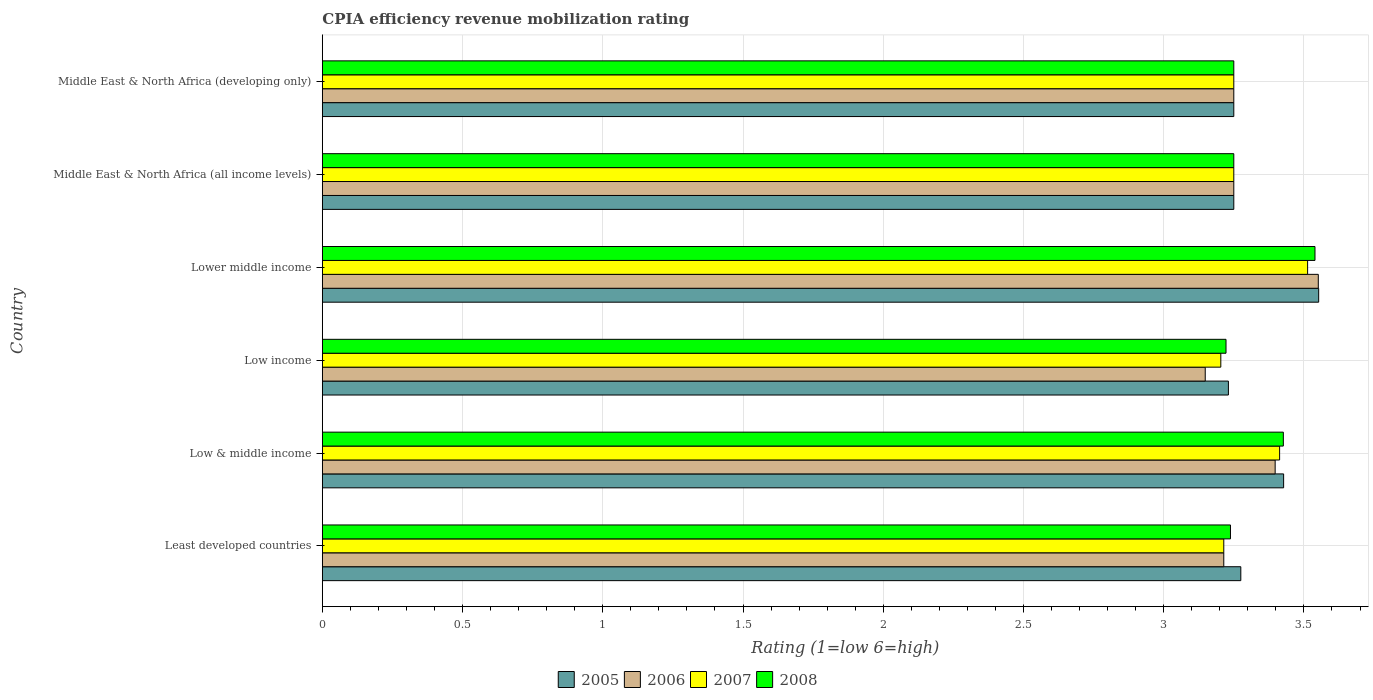How many different coloured bars are there?
Your answer should be compact. 4. How many groups of bars are there?
Keep it short and to the point. 6. Are the number of bars on each tick of the Y-axis equal?
Offer a very short reply. Yes. How many bars are there on the 6th tick from the top?
Keep it short and to the point. 4. What is the label of the 1st group of bars from the top?
Your answer should be compact. Middle East & North Africa (developing only). What is the CPIA rating in 2007 in Low & middle income?
Ensure brevity in your answer.  3.41. Across all countries, what is the maximum CPIA rating in 2008?
Ensure brevity in your answer.  3.54. Across all countries, what is the minimum CPIA rating in 2008?
Keep it short and to the point. 3.22. In which country was the CPIA rating in 2006 maximum?
Your answer should be very brief. Lower middle income. What is the total CPIA rating in 2006 in the graph?
Your answer should be compact. 19.81. What is the difference between the CPIA rating in 2006 in Least developed countries and that in Middle East & North Africa (developing only)?
Provide a succinct answer. -0.04. What is the difference between the CPIA rating in 2008 in Middle East & North Africa (all income levels) and the CPIA rating in 2007 in Low & middle income?
Offer a terse response. -0.16. What is the average CPIA rating in 2006 per country?
Ensure brevity in your answer.  3.3. What is the difference between the CPIA rating in 2006 and CPIA rating in 2008 in Least developed countries?
Give a very brief answer. -0.02. What is the ratio of the CPIA rating in 2008 in Least developed countries to that in Low & middle income?
Your answer should be compact. 0.94. Is the CPIA rating in 2008 in Low & middle income less than that in Middle East & North Africa (all income levels)?
Offer a terse response. No. Is the difference between the CPIA rating in 2006 in Lower middle income and Middle East & North Africa (developing only) greater than the difference between the CPIA rating in 2008 in Lower middle income and Middle East & North Africa (developing only)?
Your answer should be compact. Yes. What is the difference between the highest and the lowest CPIA rating in 2008?
Your answer should be very brief. 0.32. In how many countries, is the CPIA rating in 2007 greater than the average CPIA rating in 2007 taken over all countries?
Provide a succinct answer. 2. Is it the case that in every country, the sum of the CPIA rating in 2007 and CPIA rating in 2008 is greater than the sum of CPIA rating in 2005 and CPIA rating in 2006?
Provide a short and direct response. No. What does the 1st bar from the top in Middle East & North Africa (developing only) represents?
Make the answer very short. 2008. Is it the case that in every country, the sum of the CPIA rating in 2007 and CPIA rating in 2008 is greater than the CPIA rating in 2005?
Your response must be concise. Yes. What is the difference between two consecutive major ticks on the X-axis?
Keep it short and to the point. 0.5. Does the graph contain any zero values?
Offer a very short reply. No. Where does the legend appear in the graph?
Your response must be concise. Bottom center. What is the title of the graph?
Offer a very short reply. CPIA efficiency revenue mobilization rating. Does "2007" appear as one of the legend labels in the graph?
Your answer should be very brief. Yes. What is the label or title of the X-axis?
Provide a succinct answer. Rating (1=low 6=high). What is the label or title of the Y-axis?
Provide a short and direct response. Country. What is the Rating (1=low 6=high) in 2005 in Least developed countries?
Offer a very short reply. 3.27. What is the Rating (1=low 6=high) in 2006 in Least developed countries?
Keep it short and to the point. 3.21. What is the Rating (1=low 6=high) of 2007 in Least developed countries?
Give a very brief answer. 3.21. What is the Rating (1=low 6=high) of 2008 in Least developed countries?
Offer a terse response. 3.24. What is the Rating (1=low 6=high) of 2005 in Low & middle income?
Make the answer very short. 3.43. What is the Rating (1=low 6=high) of 2006 in Low & middle income?
Your answer should be compact. 3.4. What is the Rating (1=low 6=high) in 2007 in Low & middle income?
Provide a succinct answer. 3.41. What is the Rating (1=low 6=high) in 2008 in Low & middle income?
Your answer should be very brief. 3.43. What is the Rating (1=low 6=high) of 2005 in Low income?
Provide a succinct answer. 3.23. What is the Rating (1=low 6=high) in 2006 in Low income?
Ensure brevity in your answer.  3.15. What is the Rating (1=low 6=high) of 2007 in Low income?
Offer a very short reply. 3.2. What is the Rating (1=low 6=high) in 2008 in Low income?
Provide a short and direct response. 3.22. What is the Rating (1=low 6=high) of 2005 in Lower middle income?
Provide a succinct answer. 3.55. What is the Rating (1=low 6=high) of 2006 in Lower middle income?
Your response must be concise. 3.55. What is the Rating (1=low 6=high) of 2007 in Lower middle income?
Make the answer very short. 3.51. What is the Rating (1=low 6=high) of 2008 in Lower middle income?
Offer a terse response. 3.54. What is the Rating (1=low 6=high) of 2005 in Middle East & North Africa (all income levels)?
Provide a short and direct response. 3.25. What is the Rating (1=low 6=high) of 2007 in Middle East & North Africa (all income levels)?
Keep it short and to the point. 3.25. What is the Rating (1=low 6=high) of 2008 in Middle East & North Africa (all income levels)?
Your answer should be very brief. 3.25. What is the Rating (1=low 6=high) of 2005 in Middle East & North Africa (developing only)?
Your answer should be compact. 3.25. What is the Rating (1=low 6=high) in 2008 in Middle East & North Africa (developing only)?
Offer a terse response. 3.25. Across all countries, what is the maximum Rating (1=low 6=high) of 2005?
Make the answer very short. 3.55. Across all countries, what is the maximum Rating (1=low 6=high) of 2006?
Give a very brief answer. 3.55. Across all countries, what is the maximum Rating (1=low 6=high) in 2007?
Your answer should be compact. 3.51. Across all countries, what is the maximum Rating (1=low 6=high) in 2008?
Keep it short and to the point. 3.54. Across all countries, what is the minimum Rating (1=low 6=high) of 2005?
Your response must be concise. 3.23. Across all countries, what is the minimum Rating (1=low 6=high) in 2006?
Ensure brevity in your answer.  3.15. Across all countries, what is the minimum Rating (1=low 6=high) of 2007?
Give a very brief answer. 3.2. Across all countries, what is the minimum Rating (1=low 6=high) of 2008?
Give a very brief answer. 3.22. What is the total Rating (1=low 6=high) of 2005 in the graph?
Your answer should be compact. 19.99. What is the total Rating (1=low 6=high) in 2006 in the graph?
Your answer should be compact. 19.81. What is the total Rating (1=low 6=high) of 2007 in the graph?
Your answer should be very brief. 19.84. What is the total Rating (1=low 6=high) in 2008 in the graph?
Offer a very short reply. 19.93. What is the difference between the Rating (1=low 6=high) of 2005 in Least developed countries and that in Low & middle income?
Ensure brevity in your answer.  -0.15. What is the difference between the Rating (1=low 6=high) in 2006 in Least developed countries and that in Low & middle income?
Your response must be concise. -0.18. What is the difference between the Rating (1=low 6=high) of 2007 in Least developed countries and that in Low & middle income?
Make the answer very short. -0.2. What is the difference between the Rating (1=low 6=high) in 2008 in Least developed countries and that in Low & middle income?
Offer a very short reply. -0.19. What is the difference between the Rating (1=low 6=high) of 2005 in Least developed countries and that in Low income?
Ensure brevity in your answer.  0.04. What is the difference between the Rating (1=low 6=high) in 2006 in Least developed countries and that in Low income?
Your answer should be very brief. 0.07. What is the difference between the Rating (1=low 6=high) of 2007 in Least developed countries and that in Low income?
Keep it short and to the point. 0.01. What is the difference between the Rating (1=low 6=high) in 2008 in Least developed countries and that in Low income?
Your response must be concise. 0.02. What is the difference between the Rating (1=low 6=high) of 2005 in Least developed countries and that in Lower middle income?
Your answer should be compact. -0.28. What is the difference between the Rating (1=low 6=high) in 2006 in Least developed countries and that in Lower middle income?
Provide a succinct answer. -0.34. What is the difference between the Rating (1=low 6=high) of 2007 in Least developed countries and that in Lower middle income?
Your answer should be compact. -0.3. What is the difference between the Rating (1=low 6=high) in 2008 in Least developed countries and that in Lower middle income?
Offer a terse response. -0.3. What is the difference between the Rating (1=low 6=high) of 2005 in Least developed countries and that in Middle East & North Africa (all income levels)?
Ensure brevity in your answer.  0.03. What is the difference between the Rating (1=low 6=high) in 2006 in Least developed countries and that in Middle East & North Africa (all income levels)?
Offer a very short reply. -0.04. What is the difference between the Rating (1=low 6=high) of 2007 in Least developed countries and that in Middle East & North Africa (all income levels)?
Make the answer very short. -0.04. What is the difference between the Rating (1=low 6=high) in 2008 in Least developed countries and that in Middle East & North Africa (all income levels)?
Provide a short and direct response. -0.01. What is the difference between the Rating (1=low 6=high) of 2005 in Least developed countries and that in Middle East & North Africa (developing only)?
Give a very brief answer. 0.03. What is the difference between the Rating (1=low 6=high) of 2006 in Least developed countries and that in Middle East & North Africa (developing only)?
Give a very brief answer. -0.04. What is the difference between the Rating (1=low 6=high) of 2007 in Least developed countries and that in Middle East & North Africa (developing only)?
Make the answer very short. -0.04. What is the difference between the Rating (1=low 6=high) of 2008 in Least developed countries and that in Middle East & North Africa (developing only)?
Ensure brevity in your answer.  -0.01. What is the difference between the Rating (1=low 6=high) in 2005 in Low & middle income and that in Low income?
Keep it short and to the point. 0.2. What is the difference between the Rating (1=low 6=high) of 2006 in Low & middle income and that in Low income?
Give a very brief answer. 0.25. What is the difference between the Rating (1=low 6=high) of 2007 in Low & middle income and that in Low income?
Keep it short and to the point. 0.21. What is the difference between the Rating (1=low 6=high) in 2008 in Low & middle income and that in Low income?
Provide a succinct answer. 0.2. What is the difference between the Rating (1=low 6=high) of 2005 in Low & middle income and that in Lower middle income?
Make the answer very short. -0.12. What is the difference between the Rating (1=low 6=high) in 2006 in Low & middle income and that in Lower middle income?
Provide a succinct answer. -0.15. What is the difference between the Rating (1=low 6=high) of 2007 in Low & middle income and that in Lower middle income?
Ensure brevity in your answer.  -0.1. What is the difference between the Rating (1=low 6=high) of 2008 in Low & middle income and that in Lower middle income?
Your answer should be very brief. -0.11. What is the difference between the Rating (1=low 6=high) of 2005 in Low & middle income and that in Middle East & North Africa (all income levels)?
Give a very brief answer. 0.18. What is the difference between the Rating (1=low 6=high) in 2006 in Low & middle income and that in Middle East & North Africa (all income levels)?
Your response must be concise. 0.15. What is the difference between the Rating (1=low 6=high) in 2007 in Low & middle income and that in Middle East & North Africa (all income levels)?
Make the answer very short. 0.16. What is the difference between the Rating (1=low 6=high) in 2008 in Low & middle income and that in Middle East & North Africa (all income levels)?
Provide a succinct answer. 0.18. What is the difference between the Rating (1=low 6=high) of 2005 in Low & middle income and that in Middle East & North Africa (developing only)?
Give a very brief answer. 0.18. What is the difference between the Rating (1=low 6=high) of 2006 in Low & middle income and that in Middle East & North Africa (developing only)?
Offer a terse response. 0.15. What is the difference between the Rating (1=low 6=high) in 2007 in Low & middle income and that in Middle East & North Africa (developing only)?
Ensure brevity in your answer.  0.16. What is the difference between the Rating (1=low 6=high) of 2008 in Low & middle income and that in Middle East & North Africa (developing only)?
Provide a succinct answer. 0.18. What is the difference between the Rating (1=low 6=high) in 2005 in Low income and that in Lower middle income?
Ensure brevity in your answer.  -0.32. What is the difference between the Rating (1=low 6=high) of 2006 in Low income and that in Lower middle income?
Your answer should be compact. -0.4. What is the difference between the Rating (1=low 6=high) of 2007 in Low income and that in Lower middle income?
Give a very brief answer. -0.31. What is the difference between the Rating (1=low 6=high) in 2008 in Low income and that in Lower middle income?
Keep it short and to the point. -0.32. What is the difference between the Rating (1=low 6=high) of 2005 in Low income and that in Middle East & North Africa (all income levels)?
Keep it short and to the point. -0.02. What is the difference between the Rating (1=low 6=high) in 2006 in Low income and that in Middle East & North Africa (all income levels)?
Offer a terse response. -0.1. What is the difference between the Rating (1=low 6=high) in 2007 in Low income and that in Middle East & North Africa (all income levels)?
Provide a short and direct response. -0.05. What is the difference between the Rating (1=low 6=high) of 2008 in Low income and that in Middle East & North Africa (all income levels)?
Provide a short and direct response. -0.03. What is the difference between the Rating (1=low 6=high) in 2005 in Low income and that in Middle East & North Africa (developing only)?
Offer a terse response. -0.02. What is the difference between the Rating (1=low 6=high) in 2006 in Low income and that in Middle East & North Africa (developing only)?
Give a very brief answer. -0.1. What is the difference between the Rating (1=low 6=high) of 2007 in Low income and that in Middle East & North Africa (developing only)?
Make the answer very short. -0.05. What is the difference between the Rating (1=low 6=high) of 2008 in Low income and that in Middle East & North Africa (developing only)?
Offer a terse response. -0.03. What is the difference between the Rating (1=low 6=high) in 2005 in Lower middle income and that in Middle East & North Africa (all income levels)?
Provide a short and direct response. 0.3. What is the difference between the Rating (1=low 6=high) of 2006 in Lower middle income and that in Middle East & North Africa (all income levels)?
Your answer should be compact. 0.3. What is the difference between the Rating (1=low 6=high) of 2007 in Lower middle income and that in Middle East & North Africa (all income levels)?
Make the answer very short. 0.26. What is the difference between the Rating (1=low 6=high) of 2008 in Lower middle income and that in Middle East & North Africa (all income levels)?
Provide a short and direct response. 0.29. What is the difference between the Rating (1=low 6=high) in 2005 in Lower middle income and that in Middle East & North Africa (developing only)?
Offer a terse response. 0.3. What is the difference between the Rating (1=low 6=high) of 2006 in Lower middle income and that in Middle East & North Africa (developing only)?
Give a very brief answer. 0.3. What is the difference between the Rating (1=low 6=high) of 2007 in Lower middle income and that in Middle East & North Africa (developing only)?
Offer a terse response. 0.26. What is the difference between the Rating (1=low 6=high) in 2008 in Lower middle income and that in Middle East & North Africa (developing only)?
Give a very brief answer. 0.29. What is the difference between the Rating (1=low 6=high) of 2006 in Middle East & North Africa (all income levels) and that in Middle East & North Africa (developing only)?
Provide a short and direct response. 0. What is the difference between the Rating (1=low 6=high) of 2008 in Middle East & North Africa (all income levels) and that in Middle East & North Africa (developing only)?
Give a very brief answer. 0. What is the difference between the Rating (1=low 6=high) of 2005 in Least developed countries and the Rating (1=low 6=high) of 2006 in Low & middle income?
Keep it short and to the point. -0.12. What is the difference between the Rating (1=low 6=high) in 2005 in Least developed countries and the Rating (1=low 6=high) in 2007 in Low & middle income?
Your answer should be compact. -0.14. What is the difference between the Rating (1=low 6=high) in 2005 in Least developed countries and the Rating (1=low 6=high) in 2008 in Low & middle income?
Give a very brief answer. -0.15. What is the difference between the Rating (1=low 6=high) in 2006 in Least developed countries and the Rating (1=low 6=high) in 2007 in Low & middle income?
Provide a short and direct response. -0.2. What is the difference between the Rating (1=low 6=high) of 2006 in Least developed countries and the Rating (1=low 6=high) of 2008 in Low & middle income?
Offer a very short reply. -0.21. What is the difference between the Rating (1=low 6=high) of 2007 in Least developed countries and the Rating (1=low 6=high) of 2008 in Low & middle income?
Your response must be concise. -0.21. What is the difference between the Rating (1=low 6=high) in 2005 in Least developed countries and the Rating (1=low 6=high) in 2006 in Low income?
Offer a terse response. 0.13. What is the difference between the Rating (1=low 6=high) of 2005 in Least developed countries and the Rating (1=low 6=high) of 2007 in Low income?
Offer a very short reply. 0.07. What is the difference between the Rating (1=low 6=high) in 2005 in Least developed countries and the Rating (1=low 6=high) in 2008 in Low income?
Offer a very short reply. 0.05. What is the difference between the Rating (1=low 6=high) in 2006 in Least developed countries and the Rating (1=low 6=high) in 2007 in Low income?
Your answer should be compact. 0.01. What is the difference between the Rating (1=low 6=high) of 2006 in Least developed countries and the Rating (1=low 6=high) of 2008 in Low income?
Provide a succinct answer. -0.01. What is the difference between the Rating (1=low 6=high) in 2007 in Least developed countries and the Rating (1=low 6=high) in 2008 in Low income?
Provide a succinct answer. -0.01. What is the difference between the Rating (1=low 6=high) of 2005 in Least developed countries and the Rating (1=low 6=high) of 2006 in Lower middle income?
Give a very brief answer. -0.28. What is the difference between the Rating (1=low 6=high) in 2005 in Least developed countries and the Rating (1=low 6=high) in 2007 in Lower middle income?
Provide a short and direct response. -0.24. What is the difference between the Rating (1=low 6=high) in 2005 in Least developed countries and the Rating (1=low 6=high) in 2008 in Lower middle income?
Give a very brief answer. -0.26. What is the difference between the Rating (1=low 6=high) in 2006 in Least developed countries and the Rating (1=low 6=high) in 2007 in Lower middle income?
Your answer should be very brief. -0.3. What is the difference between the Rating (1=low 6=high) in 2006 in Least developed countries and the Rating (1=low 6=high) in 2008 in Lower middle income?
Provide a short and direct response. -0.33. What is the difference between the Rating (1=low 6=high) in 2007 in Least developed countries and the Rating (1=low 6=high) in 2008 in Lower middle income?
Give a very brief answer. -0.33. What is the difference between the Rating (1=low 6=high) in 2005 in Least developed countries and the Rating (1=low 6=high) in 2006 in Middle East & North Africa (all income levels)?
Ensure brevity in your answer.  0.03. What is the difference between the Rating (1=low 6=high) in 2005 in Least developed countries and the Rating (1=low 6=high) in 2007 in Middle East & North Africa (all income levels)?
Offer a very short reply. 0.03. What is the difference between the Rating (1=low 6=high) of 2005 in Least developed countries and the Rating (1=low 6=high) of 2008 in Middle East & North Africa (all income levels)?
Offer a very short reply. 0.03. What is the difference between the Rating (1=low 6=high) of 2006 in Least developed countries and the Rating (1=low 6=high) of 2007 in Middle East & North Africa (all income levels)?
Provide a short and direct response. -0.04. What is the difference between the Rating (1=low 6=high) in 2006 in Least developed countries and the Rating (1=low 6=high) in 2008 in Middle East & North Africa (all income levels)?
Make the answer very short. -0.04. What is the difference between the Rating (1=low 6=high) of 2007 in Least developed countries and the Rating (1=low 6=high) of 2008 in Middle East & North Africa (all income levels)?
Your answer should be very brief. -0.04. What is the difference between the Rating (1=low 6=high) in 2005 in Least developed countries and the Rating (1=low 6=high) in 2006 in Middle East & North Africa (developing only)?
Make the answer very short. 0.03. What is the difference between the Rating (1=low 6=high) in 2005 in Least developed countries and the Rating (1=low 6=high) in 2007 in Middle East & North Africa (developing only)?
Provide a short and direct response. 0.03. What is the difference between the Rating (1=low 6=high) of 2005 in Least developed countries and the Rating (1=low 6=high) of 2008 in Middle East & North Africa (developing only)?
Make the answer very short. 0.03. What is the difference between the Rating (1=low 6=high) in 2006 in Least developed countries and the Rating (1=low 6=high) in 2007 in Middle East & North Africa (developing only)?
Your answer should be compact. -0.04. What is the difference between the Rating (1=low 6=high) in 2006 in Least developed countries and the Rating (1=low 6=high) in 2008 in Middle East & North Africa (developing only)?
Offer a very short reply. -0.04. What is the difference between the Rating (1=low 6=high) in 2007 in Least developed countries and the Rating (1=low 6=high) in 2008 in Middle East & North Africa (developing only)?
Offer a terse response. -0.04. What is the difference between the Rating (1=low 6=high) of 2005 in Low & middle income and the Rating (1=low 6=high) of 2006 in Low income?
Ensure brevity in your answer.  0.28. What is the difference between the Rating (1=low 6=high) of 2005 in Low & middle income and the Rating (1=low 6=high) of 2007 in Low income?
Offer a terse response. 0.22. What is the difference between the Rating (1=low 6=high) of 2005 in Low & middle income and the Rating (1=low 6=high) of 2008 in Low income?
Give a very brief answer. 0.21. What is the difference between the Rating (1=low 6=high) of 2006 in Low & middle income and the Rating (1=low 6=high) of 2007 in Low income?
Keep it short and to the point. 0.19. What is the difference between the Rating (1=low 6=high) of 2006 in Low & middle income and the Rating (1=low 6=high) of 2008 in Low income?
Make the answer very short. 0.18. What is the difference between the Rating (1=low 6=high) in 2007 in Low & middle income and the Rating (1=low 6=high) in 2008 in Low income?
Your response must be concise. 0.19. What is the difference between the Rating (1=low 6=high) in 2005 in Low & middle income and the Rating (1=low 6=high) in 2006 in Lower middle income?
Offer a terse response. -0.12. What is the difference between the Rating (1=low 6=high) in 2005 in Low & middle income and the Rating (1=low 6=high) in 2007 in Lower middle income?
Keep it short and to the point. -0.09. What is the difference between the Rating (1=low 6=high) of 2005 in Low & middle income and the Rating (1=low 6=high) of 2008 in Lower middle income?
Give a very brief answer. -0.11. What is the difference between the Rating (1=low 6=high) in 2006 in Low & middle income and the Rating (1=low 6=high) in 2007 in Lower middle income?
Offer a terse response. -0.12. What is the difference between the Rating (1=low 6=high) in 2006 in Low & middle income and the Rating (1=low 6=high) in 2008 in Lower middle income?
Ensure brevity in your answer.  -0.14. What is the difference between the Rating (1=low 6=high) of 2007 in Low & middle income and the Rating (1=low 6=high) of 2008 in Lower middle income?
Provide a succinct answer. -0.13. What is the difference between the Rating (1=low 6=high) of 2005 in Low & middle income and the Rating (1=low 6=high) of 2006 in Middle East & North Africa (all income levels)?
Your response must be concise. 0.18. What is the difference between the Rating (1=low 6=high) of 2005 in Low & middle income and the Rating (1=low 6=high) of 2007 in Middle East & North Africa (all income levels)?
Your answer should be very brief. 0.18. What is the difference between the Rating (1=low 6=high) of 2005 in Low & middle income and the Rating (1=low 6=high) of 2008 in Middle East & North Africa (all income levels)?
Provide a succinct answer. 0.18. What is the difference between the Rating (1=low 6=high) of 2006 in Low & middle income and the Rating (1=low 6=high) of 2007 in Middle East & North Africa (all income levels)?
Ensure brevity in your answer.  0.15. What is the difference between the Rating (1=low 6=high) in 2006 in Low & middle income and the Rating (1=low 6=high) in 2008 in Middle East & North Africa (all income levels)?
Your answer should be very brief. 0.15. What is the difference between the Rating (1=low 6=high) of 2007 in Low & middle income and the Rating (1=low 6=high) of 2008 in Middle East & North Africa (all income levels)?
Offer a terse response. 0.16. What is the difference between the Rating (1=low 6=high) in 2005 in Low & middle income and the Rating (1=low 6=high) in 2006 in Middle East & North Africa (developing only)?
Your answer should be compact. 0.18. What is the difference between the Rating (1=low 6=high) in 2005 in Low & middle income and the Rating (1=low 6=high) in 2007 in Middle East & North Africa (developing only)?
Give a very brief answer. 0.18. What is the difference between the Rating (1=low 6=high) of 2005 in Low & middle income and the Rating (1=low 6=high) of 2008 in Middle East & North Africa (developing only)?
Keep it short and to the point. 0.18. What is the difference between the Rating (1=low 6=high) in 2006 in Low & middle income and the Rating (1=low 6=high) in 2007 in Middle East & North Africa (developing only)?
Ensure brevity in your answer.  0.15. What is the difference between the Rating (1=low 6=high) of 2006 in Low & middle income and the Rating (1=low 6=high) of 2008 in Middle East & North Africa (developing only)?
Provide a succinct answer. 0.15. What is the difference between the Rating (1=low 6=high) of 2007 in Low & middle income and the Rating (1=low 6=high) of 2008 in Middle East & North Africa (developing only)?
Provide a succinct answer. 0.16. What is the difference between the Rating (1=low 6=high) in 2005 in Low income and the Rating (1=low 6=high) in 2006 in Lower middle income?
Ensure brevity in your answer.  -0.32. What is the difference between the Rating (1=low 6=high) of 2005 in Low income and the Rating (1=low 6=high) of 2007 in Lower middle income?
Offer a very short reply. -0.28. What is the difference between the Rating (1=low 6=high) of 2005 in Low income and the Rating (1=low 6=high) of 2008 in Lower middle income?
Provide a short and direct response. -0.31. What is the difference between the Rating (1=low 6=high) in 2006 in Low income and the Rating (1=low 6=high) in 2007 in Lower middle income?
Your response must be concise. -0.36. What is the difference between the Rating (1=low 6=high) of 2006 in Low income and the Rating (1=low 6=high) of 2008 in Lower middle income?
Your response must be concise. -0.39. What is the difference between the Rating (1=low 6=high) in 2007 in Low income and the Rating (1=low 6=high) in 2008 in Lower middle income?
Ensure brevity in your answer.  -0.34. What is the difference between the Rating (1=low 6=high) in 2005 in Low income and the Rating (1=low 6=high) in 2006 in Middle East & North Africa (all income levels)?
Provide a short and direct response. -0.02. What is the difference between the Rating (1=low 6=high) of 2005 in Low income and the Rating (1=low 6=high) of 2007 in Middle East & North Africa (all income levels)?
Make the answer very short. -0.02. What is the difference between the Rating (1=low 6=high) in 2005 in Low income and the Rating (1=low 6=high) in 2008 in Middle East & North Africa (all income levels)?
Ensure brevity in your answer.  -0.02. What is the difference between the Rating (1=low 6=high) in 2006 in Low income and the Rating (1=low 6=high) in 2007 in Middle East & North Africa (all income levels)?
Offer a terse response. -0.1. What is the difference between the Rating (1=low 6=high) of 2006 in Low income and the Rating (1=low 6=high) of 2008 in Middle East & North Africa (all income levels)?
Ensure brevity in your answer.  -0.1. What is the difference between the Rating (1=low 6=high) of 2007 in Low income and the Rating (1=low 6=high) of 2008 in Middle East & North Africa (all income levels)?
Ensure brevity in your answer.  -0.05. What is the difference between the Rating (1=low 6=high) in 2005 in Low income and the Rating (1=low 6=high) in 2006 in Middle East & North Africa (developing only)?
Make the answer very short. -0.02. What is the difference between the Rating (1=low 6=high) in 2005 in Low income and the Rating (1=low 6=high) in 2007 in Middle East & North Africa (developing only)?
Ensure brevity in your answer.  -0.02. What is the difference between the Rating (1=low 6=high) in 2005 in Low income and the Rating (1=low 6=high) in 2008 in Middle East & North Africa (developing only)?
Offer a very short reply. -0.02. What is the difference between the Rating (1=low 6=high) in 2006 in Low income and the Rating (1=low 6=high) in 2007 in Middle East & North Africa (developing only)?
Offer a terse response. -0.1. What is the difference between the Rating (1=low 6=high) of 2006 in Low income and the Rating (1=low 6=high) of 2008 in Middle East & North Africa (developing only)?
Provide a succinct answer. -0.1. What is the difference between the Rating (1=low 6=high) in 2007 in Low income and the Rating (1=low 6=high) in 2008 in Middle East & North Africa (developing only)?
Your answer should be compact. -0.05. What is the difference between the Rating (1=low 6=high) in 2005 in Lower middle income and the Rating (1=low 6=high) in 2006 in Middle East & North Africa (all income levels)?
Offer a terse response. 0.3. What is the difference between the Rating (1=low 6=high) of 2005 in Lower middle income and the Rating (1=low 6=high) of 2007 in Middle East & North Africa (all income levels)?
Make the answer very short. 0.3. What is the difference between the Rating (1=low 6=high) of 2005 in Lower middle income and the Rating (1=low 6=high) of 2008 in Middle East & North Africa (all income levels)?
Your answer should be compact. 0.3. What is the difference between the Rating (1=low 6=high) of 2006 in Lower middle income and the Rating (1=low 6=high) of 2007 in Middle East & North Africa (all income levels)?
Provide a short and direct response. 0.3. What is the difference between the Rating (1=low 6=high) of 2006 in Lower middle income and the Rating (1=low 6=high) of 2008 in Middle East & North Africa (all income levels)?
Keep it short and to the point. 0.3. What is the difference between the Rating (1=low 6=high) in 2007 in Lower middle income and the Rating (1=low 6=high) in 2008 in Middle East & North Africa (all income levels)?
Your answer should be very brief. 0.26. What is the difference between the Rating (1=low 6=high) of 2005 in Lower middle income and the Rating (1=low 6=high) of 2006 in Middle East & North Africa (developing only)?
Provide a succinct answer. 0.3. What is the difference between the Rating (1=low 6=high) in 2005 in Lower middle income and the Rating (1=low 6=high) in 2007 in Middle East & North Africa (developing only)?
Your answer should be very brief. 0.3. What is the difference between the Rating (1=low 6=high) in 2005 in Lower middle income and the Rating (1=low 6=high) in 2008 in Middle East & North Africa (developing only)?
Give a very brief answer. 0.3. What is the difference between the Rating (1=low 6=high) in 2006 in Lower middle income and the Rating (1=low 6=high) in 2007 in Middle East & North Africa (developing only)?
Your answer should be compact. 0.3. What is the difference between the Rating (1=low 6=high) of 2006 in Lower middle income and the Rating (1=low 6=high) of 2008 in Middle East & North Africa (developing only)?
Provide a succinct answer. 0.3. What is the difference between the Rating (1=low 6=high) of 2007 in Lower middle income and the Rating (1=low 6=high) of 2008 in Middle East & North Africa (developing only)?
Offer a very short reply. 0.26. What is the difference between the Rating (1=low 6=high) of 2006 in Middle East & North Africa (all income levels) and the Rating (1=low 6=high) of 2008 in Middle East & North Africa (developing only)?
Offer a very short reply. 0. What is the difference between the Rating (1=low 6=high) of 2007 in Middle East & North Africa (all income levels) and the Rating (1=low 6=high) of 2008 in Middle East & North Africa (developing only)?
Ensure brevity in your answer.  0. What is the average Rating (1=low 6=high) of 2005 per country?
Offer a terse response. 3.33. What is the average Rating (1=low 6=high) in 2006 per country?
Your answer should be compact. 3.3. What is the average Rating (1=low 6=high) in 2007 per country?
Keep it short and to the point. 3.31. What is the average Rating (1=low 6=high) in 2008 per country?
Provide a succinct answer. 3.32. What is the difference between the Rating (1=low 6=high) of 2005 and Rating (1=low 6=high) of 2006 in Least developed countries?
Ensure brevity in your answer.  0.06. What is the difference between the Rating (1=low 6=high) in 2005 and Rating (1=low 6=high) in 2007 in Least developed countries?
Give a very brief answer. 0.06. What is the difference between the Rating (1=low 6=high) in 2005 and Rating (1=low 6=high) in 2008 in Least developed countries?
Give a very brief answer. 0.04. What is the difference between the Rating (1=low 6=high) of 2006 and Rating (1=low 6=high) of 2008 in Least developed countries?
Ensure brevity in your answer.  -0.02. What is the difference between the Rating (1=low 6=high) of 2007 and Rating (1=low 6=high) of 2008 in Least developed countries?
Give a very brief answer. -0.02. What is the difference between the Rating (1=low 6=high) in 2005 and Rating (1=low 6=high) in 2006 in Low & middle income?
Your answer should be compact. 0.03. What is the difference between the Rating (1=low 6=high) of 2005 and Rating (1=low 6=high) of 2007 in Low & middle income?
Ensure brevity in your answer.  0.01. What is the difference between the Rating (1=low 6=high) in 2006 and Rating (1=low 6=high) in 2007 in Low & middle income?
Keep it short and to the point. -0.02. What is the difference between the Rating (1=low 6=high) in 2006 and Rating (1=low 6=high) in 2008 in Low & middle income?
Offer a terse response. -0.03. What is the difference between the Rating (1=low 6=high) of 2007 and Rating (1=low 6=high) of 2008 in Low & middle income?
Your response must be concise. -0.01. What is the difference between the Rating (1=low 6=high) in 2005 and Rating (1=low 6=high) in 2006 in Low income?
Your answer should be compact. 0.08. What is the difference between the Rating (1=low 6=high) in 2005 and Rating (1=low 6=high) in 2007 in Low income?
Make the answer very short. 0.03. What is the difference between the Rating (1=low 6=high) of 2005 and Rating (1=low 6=high) of 2008 in Low income?
Ensure brevity in your answer.  0.01. What is the difference between the Rating (1=low 6=high) of 2006 and Rating (1=low 6=high) of 2007 in Low income?
Provide a succinct answer. -0.06. What is the difference between the Rating (1=low 6=high) in 2006 and Rating (1=low 6=high) in 2008 in Low income?
Your response must be concise. -0.07. What is the difference between the Rating (1=low 6=high) of 2007 and Rating (1=low 6=high) of 2008 in Low income?
Offer a terse response. -0.02. What is the difference between the Rating (1=low 6=high) of 2005 and Rating (1=low 6=high) of 2006 in Lower middle income?
Ensure brevity in your answer.  0. What is the difference between the Rating (1=low 6=high) of 2005 and Rating (1=low 6=high) of 2007 in Lower middle income?
Ensure brevity in your answer.  0.04. What is the difference between the Rating (1=low 6=high) of 2005 and Rating (1=low 6=high) of 2008 in Lower middle income?
Give a very brief answer. 0.01. What is the difference between the Rating (1=low 6=high) of 2006 and Rating (1=low 6=high) of 2007 in Lower middle income?
Ensure brevity in your answer.  0.04. What is the difference between the Rating (1=low 6=high) of 2006 and Rating (1=low 6=high) of 2008 in Lower middle income?
Offer a very short reply. 0.01. What is the difference between the Rating (1=low 6=high) in 2007 and Rating (1=low 6=high) in 2008 in Lower middle income?
Make the answer very short. -0.03. What is the difference between the Rating (1=low 6=high) of 2005 and Rating (1=low 6=high) of 2006 in Middle East & North Africa (all income levels)?
Offer a terse response. 0. What is the difference between the Rating (1=low 6=high) in 2006 and Rating (1=low 6=high) in 2007 in Middle East & North Africa (all income levels)?
Your answer should be very brief. 0. What is the difference between the Rating (1=low 6=high) of 2005 and Rating (1=low 6=high) of 2006 in Middle East & North Africa (developing only)?
Your response must be concise. 0. What is the difference between the Rating (1=low 6=high) in 2005 and Rating (1=low 6=high) in 2007 in Middle East & North Africa (developing only)?
Provide a short and direct response. 0. What is the difference between the Rating (1=low 6=high) of 2006 and Rating (1=low 6=high) of 2008 in Middle East & North Africa (developing only)?
Ensure brevity in your answer.  0. What is the difference between the Rating (1=low 6=high) of 2007 and Rating (1=low 6=high) of 2008 in Middle East & North Africa (developing only)?
Make the answer very short. 0. What is the ratio of the Rating (1=low 6=high) in 2005 in Least developed countries to that in Low & middle income?
Make the answer very short. 0.96. What is the ratio of the Rating (1=low 6=high) of 2006 in Least developed countries to that in Low & middle income?
Your response must be concise. 0.95. What is the ratio of the Rating (1=low 6=high) in 2007 in Least developed countries to that in Low & middle income?
Your answer should be compact. 0.94. What is the ratio of the Rating (1=low 6=high) in 2008 in Least developed countries to that in Low & middle income?
Offer a very short reply. 0.94. What is the ratio of the Rating (1=low 6=high) in 2005 in Least developed countries to that in Low income?
Keep it short and to the point. 1.01. What is the ratio of the Rating (1=low 6=high) of 2006 in Least developed countries to that in Low income?
Your answer should be very brief. 1.02. What is the ratio of the Rating (1=low 6=high) in 2008 in Least developed countries to that in Low income?
Your answer should be compact. 1. What is the ratio of the Rating (1=low 6=high) of 2005 in Least developed countries to that in Lower middle income?
Offer a very short reply. 0.92. What is the ratio of the Rating (1=low 6=high) of 2006 in Least developed countries to that in Lower middle income?
Make the answer very short. 0.91. What is the ratio of the Rating (1=low 6=high) of 2007 in Least developed countries to that in Lower middle income?
Give a very brief answer. 0.91. What is the ratio of the Rating (1=low 6=high) in 2008 in Least developed countries to that in Lower middle income?
Provide a short and direct response. 0.91. What is the ratio of the Rating (1=low 6=high) in 2005 in Least developed countries to that in Middle East & North Africa (all income levels)?
Offer a very short reply. 1.01. What is the ratio of the Rating (1=low 6=high) in 2006 in Least developed countries to that in Middle East & North Africa (all income levels)?
Make the answer very short. 0.99. What is the ratio of the Rating (1=low 6=high) in 2005 in Least developed countries to that in Middle East & North Africa (developing only)?
Provide a succinct answer. 1.01. What is the ratio of the Rating (1=low 6=high) in 2007 in Least developed countries to that in Middle East & North Africa (developing only)?
Provide a succinct answer. 0.99. What is the ratio of the Rating (1=low 6=high) of 2008 in Least developed countries to that in Middle East & North Africa (developing only)?
Provide a short and direct response. 1. What is the ratio of the Rating (1=low 6=high) in 2005 in Low & middle income to that in Low income?
Offer a very short reply. 1.06. What is the ratio of the Rating (1=low 6=high) of 2006 in Low & middle income to that in Low income?
Offer a very short reply. 1.08. What is the ratio of the Rating (1=low 6=high) in 2007 in Low & middle income to that in Low income?
Provide a short and direct response. 1.07. What is the ratio of the Rating (1=low 6=high) in 2008 in Low & middle income to that in Low income?
Offer a very short reply. 1.06. What is the ratio of the Rating (1=low 6=high) of 2005 in Low & middle income to that in Lower middle income?
Provide a succinct answer. 0.96. What is the ratio of the Rating (1=low 6=high) in 2006 in Low & middle income to that in Lower middle income?
Your answer should be compact. 0.96. What is the ratio of the Rating (1=low 6=high) of 2007 in Low & middle income to that in Lower middle income?
Offer a very short reply. 0.97. What is the ratio of the Rating (1=low 6=high) in 2008 in Low & middle income to that in Lower middle income?
Provide a succinct answer. 0.97. What is the ratio of the Rating (1=low 6=high) of 2005 in Low & middle income to that in Middle East & North Africa (all income levels)?
Offer a terse response. 1.05. What is the ratio of the Rating (1=low 6=high) in 2006 in Low & middle income to that in Middle East & North Africa (all income levels)?
Make the answer very short. 1.05. What is the ratio of the Rating (1=low 6=high) of 2007 in Low & middle income to that in Middle East & North Africa (all income levels)?
Your answer should be compact. 1.05. What is the ratio of the Rating (1=low 6=high) of 2008 in Low & middle income to that in Middle East & North Africa (all income levels)?
Offer a very short reply. 1.05. What is the ratio of the Rating (1=low 6=high) of 2005 in Low & middle income to that in Middle East & North Africa (developing only)?
Your response must be concise. 1.05. What is the ratio of the Rating (1=low 6=high) in 2006 in Low & middle income to that in Middle East & North Africa (developing only)?
Your answer should be compact. 1.05. What is the ratio of the Rating (1=low 6=high) in 2007 in Low & middle income to that in Middle East & North Africa (developing only)?
Keep it short and to the point. 1.05. What is the ratio of the Rating (1=low 6=high) in 2008 in Low & middle income to that in Middle East & North Africa (developing only)?
Provide a short and direct response. 1.05. What is the ratio of the Rating (1=low 6=high) in 2005 in Low income to that in Lower middle income?
Provide a short and direct response. 0.91. What is the ratio of the Rating (1=low 6=high) of 2006 in Low income to that in Lower middle income?
Provide a succinct answer. 0.89. What is the ratio of the Rating (1=low 6=high) of 2007 in Low income to that in Lower middle income?
Provide a succinct answer. 0.91. What is the ratio of the Rating (1=low 6=high) in 2008 in Low income to that in Lower middle income?
Offer a terse response. 0.91. What is the ratio of the Rating (1=low 6=high) of 2005 in Low income to that in Middle East & North Africa (all income levels)?
Offer a very short reply. 0.99. What is the ratio of the Rating (1=low 6=high) in 2006 in Low income to that in Middle East & North Africa (all income levels)?
Provide a succinct answer. 0.97. What is the ratio of the Rating (1=low 6=high) of 2007 in Low income to that in Middle East & North Africa (all income levels)?
Ensure brevity in your answer.  0.99. What is the ratio of the Rating (1=low 6=high) of 2008 in Low income to that in Middle East & North Africa (all income levels)?
Give a very brief answer. 0.99. What is the ratio of the Rating (1=low 6=high) in 2006 in Low income to that in Middle East & North Africa (developing only)?
Ensure brevity in your answer.  0.97. What is the ratio of the Rating (1=low 6=high) of 2007 in Low income to that in Middle East & North Africa (developing only)?
Ensure brevity in your answer.  0.99. What is the ratio of the Rating (1=low 6=high) of 2008 in Low income to that in Middle East & North Africa (developing only)?
Ensure brevity in your answer.  0.99. What is the ratio of the Rating (1=low 6=high) of 2005 in Lower middle income to that in Middle East & North Africa (all income levels)?
Provide a succinct answer. 1.09. What is the ratio of the Rating (1=low 6=high) in 2006 in Lower middle income to that in Middle East & North Africa (all income levels)?
Ensure brevity in your answer.  1.09. What is the ratio of the Rating (1=low 6=high) in 2007 in Lower middle income to that in Middle East & North Africa (all income levels)?
Make the answer very short. 1.08. What is the ratio of the Rating (1=low 6=high) in 2008 in Lower middle income to that in Middle East & North Africa (all income levels)?
Provide a short and direct response. 1.09. What is the ratio of the Rating (1=low 6=high) of 2005 in Lower middle income to that in Middle East & North Africa (developing only)?
Offer a terse response. 1.09. What is the ratio of the Rating (1=low 6=high) in 2006 in Lower middle income to that in Middle East & North Africa (developing only)?
Keep it short and to the point. 1.09. What is the ratio of the Rating (1=low 6=high) of 2007 in Lower middle income to that in Middle East & North Africa (developing only)?
Offer a very short reply. 1.08. What is the ratio of the Rating (1=low 6=high) in 2008 in Lower middle income to that in Middle East & North Africa (developing only)?
Keep it short and to the point. 1.09. What is the ratio of the Rating (1=low 6=high) of 2005 in Middle East & North Africa (all income levels) to that in Middle East & North Africa (developing only)?
Provide a succinct answer. 1. What is the ratio of the Rating (1=low 6=high) in 2007 in Middle East & North Africa (all income levels) to that in Middle East & North Africa (developing only)?
Provide a short and direct response. 1. What is the difference between the highest and the second highest Rating (1=low 6=high) of 2005?
Offer a terse response. 0.12. What is the difference between the highest and the second highest Rating (1=low 6=high) of 2006?
Your answer should be compact. 0.15. What is the difference between the highest and the second highest Rating (1=low 6=high) of 2007?
Offer a terse response. 0.1. What is the difference between the highest and the second highest Rating (1=low 6=high) of 2008?
Your answer should be compact. 0.11. What is the difference between the highest and the lowest Rating (1=low 6=high) of 2005?
Give a very brief answer. 0.32. What is the difference between the highest and the lowest Rating (1=low 6=high) in 2006?
Provide a short and direct response. 0.4. What is the difference between the highest and the lowest Rating (1=low 6=high) in 2007?
Make the answer very short. 0.31. What is the difference between the highest and the lowest Rating (1=low 6=high) of 2008?
Your answer should be compact. 0.32. 